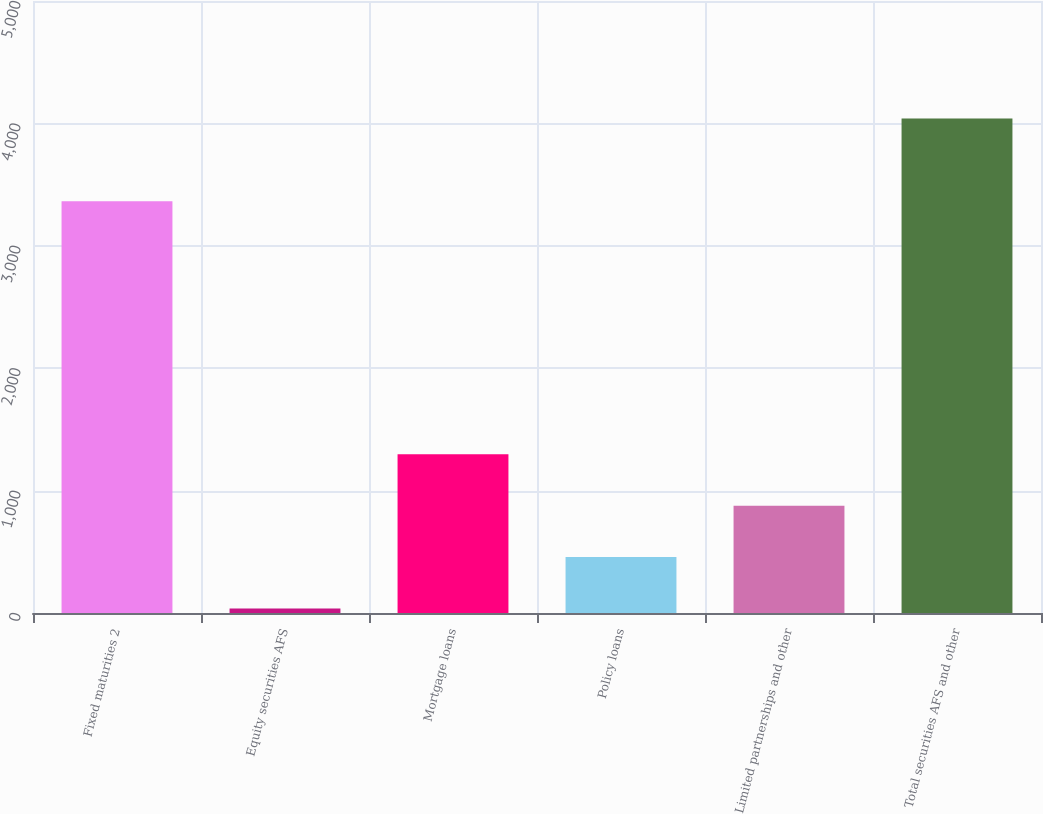Convert chart. <chart><loc_0><loc_0><loc_500><loc_500><bar_chart><fcel>Fixed maturities 2<fcel>Equity securities AFS<fcel>Mortgage loans<fcel>Policy loans<fcel>Limited partnerships and other<fcel>Total securities AFS and other<nl><fcel>3363<fcel>37<fcel>1297<fcel>457<fcel>877<fcel>4041<nl></chart> 